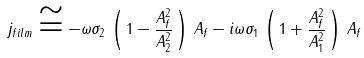<formula> <loc_0><loc_0><loc_500><loc_500>j _ { f i l m } \cong - \omega \sigma _ { 2 } \, \left ( \, 1 - \frac { A _ { f } ^ { 2 } } { A ^ { 2 } _ { 2 } } \, \right ) \, A _ { f } - i \omega \sigma _ { 1 } \, \left ( \, 1 + \frac { A _ { f } ^ { 2 } } { A ^ { 2 } _ { 1 } } \, \right ) \, A _ { f }</formula> 